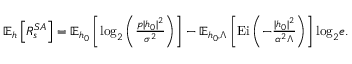Convert formula to latex. <formula><loc_0><loc_0><loc_500><loc_500>\begin{array} { r } { \mathbb { E } _ { h } \left [ R _ { s } ^ { S A } \right ] = \mathbb { E } _ { h _ { 0 } } \left [ \log _ { 2 } \left ( \frac { p | h _ { 0 } | ^ { 2 } } { \sigma ^ { 2 } } \right ) \right ] - \mathbb { E } _ { h _ { 0 } , \Lambda } \left [ E i \left ( - \frac { | h _ { 0 } | ^ { 2 } } { \alpha ^ { 2 } \Lambda } \right ) \right ] \log _ { 2 } e . } \end{array}</formula> 